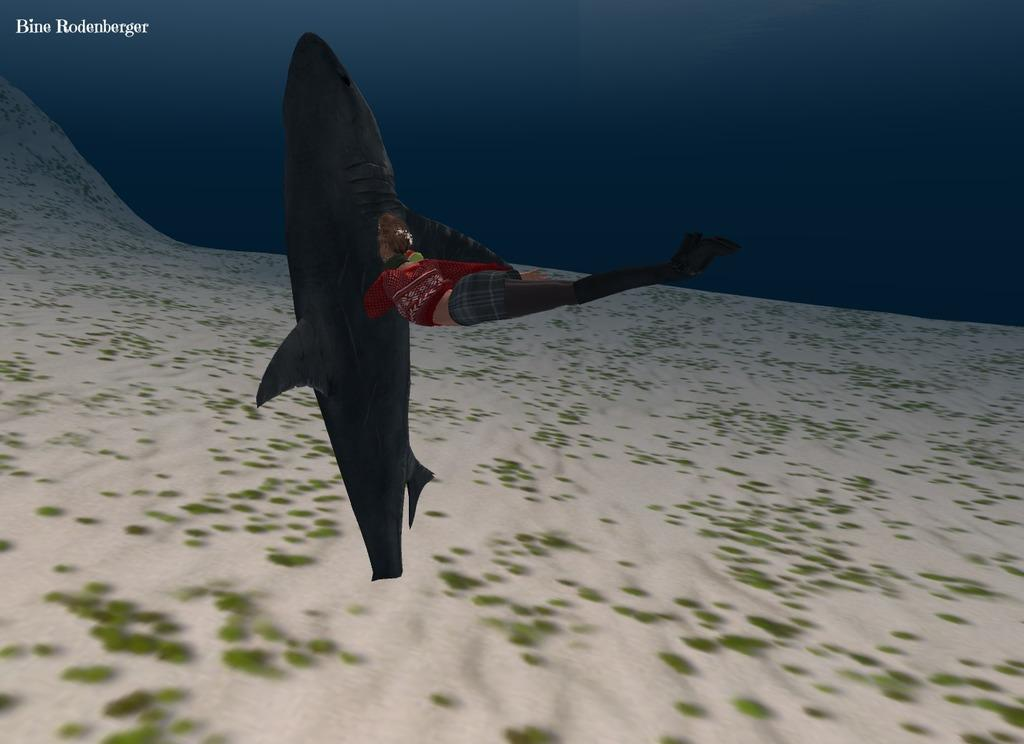What is one of the main subjects in the animation? There is a whale in the animation. Are there any human characters in the animation? Yes, there is a person in the animation. What type of environment is depicted in the animation? The animation features sand at the bottom, suggesting a beach or underwater setting. Can you tell me how many basketballs are being held by the whale in the animation? There are no basketballs present in the animation. What type of vegetable is being used as a prop by the person in the animation? There is no vegetable, such as celery, being used as a prop by the person in the animation. 